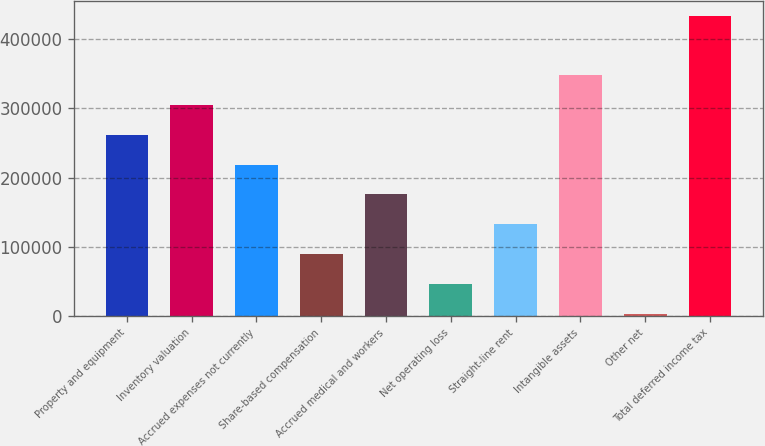Convert chart to OTSL. <chart><loc_0><loc_0><loc_500><loc_500><bar_chart><fcel>Property and equipment<fcel>Inventory valuation<fcel>Accrued expenses not currently<fcel>Share-based compensation<fcel>Accrued medical and workers<fcel>Net operating loss<fcel>Straight-line rent<fcel>Intangible assets<fcel>Other net<fcel>Total deferred income tax<nl><fcel>261714<fcel>304767<fcel>218662<fcel>89503.4<fcel>175609<fcel>46450.7<fcel>132556<fcel>347820<fcel>3398<fcel>433925<nl></chart> 